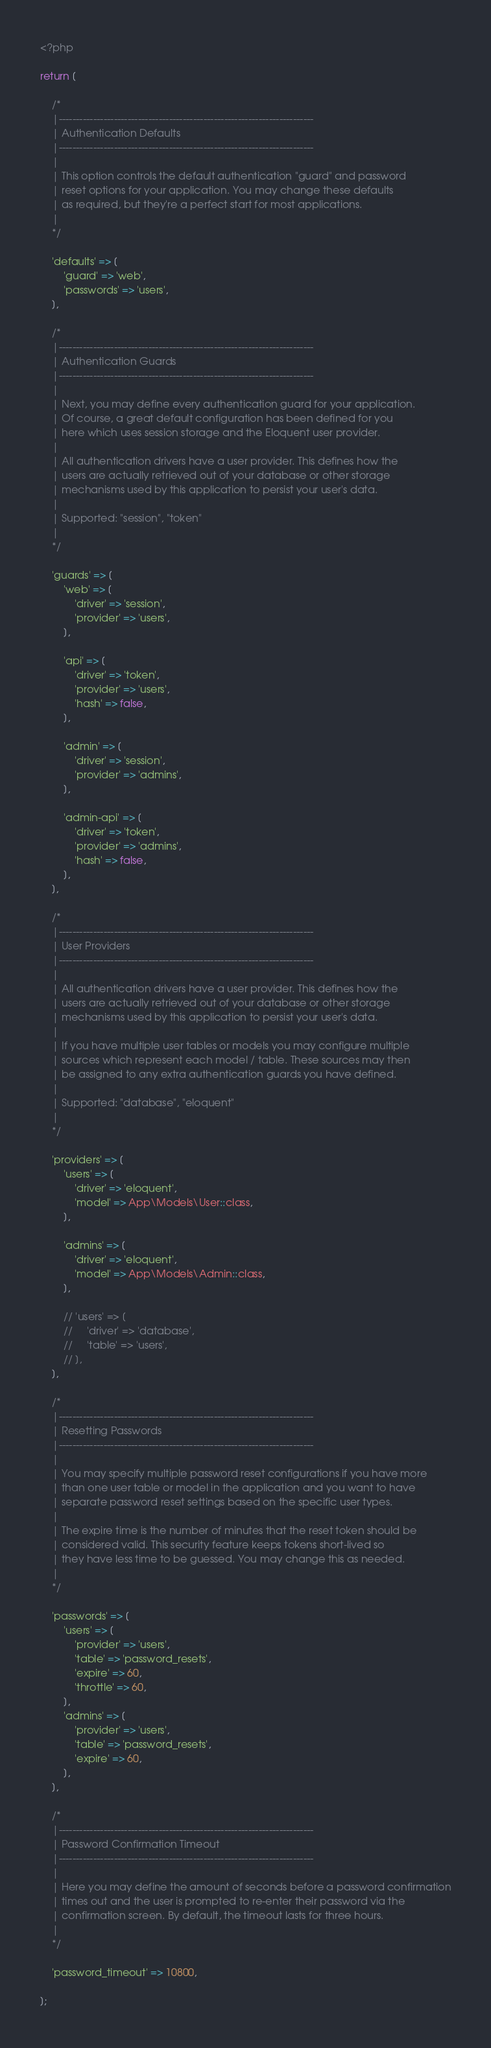<code> <loc_0><loc_0><loc_500><loc_500><_PHP_><?php

return [

    /*
    |--------------------------------------------------------------------------
    | Authentication Defaults
    |--------------------------------------------------------------------------
    |
    | This option controls the default authentication "guard" and password
    | reset options for your application. You may change these defaults
    | as required, but they're a perfect start for most applications.
    |
    */

    'defaults' => [
        'guard' => 'web',
        'passwords' => 'users',
    ],

    /*
    |--------------------------------------------------------------------------
    | Authentication Guards
    |--------------------------------------------------------------------------
    |
    | Next, you may define every authentication guard for your application.
    | Of course, a great default configuration has been defined for you
    | here which uses session storage and the Eloquent user provider.
    |
    | All authentication drivers have a user provider. This defines how the
    | users are actually retrieved out of your database or other storage
    | mechanisms used by this application to persist your user's data.
    |
    | Supported: "session", "token"
    |
    */

    'guards' => [
        'web' => [
            'driver' => 'session',
            'provider' => 'users',
        ],

        'api' => [
            'driver' => 'token',
            'provider' => 'users',
            'hash' => false,
        ],

        'admin' => [
            'driver' => 'session',
            'provider' => 'admins',
        ],
    
        'admin-api' => [
            'driver' => 'token',
            'provider' => 'admins',
            'hash' => false,
        ],
    ],

    /*
    |--------------------------------------------------------------------------
    | User Providers
    |--------------------------------------------------------------------------
    |
    | All authentication drivers have a user provider. This defines how the
    | users are actually retrieved out of your database or other storage
    | mechanisms used by this application to persist your user's data.
    |
    | If you have multiple user tables or models you may configure multiple
    | sources which represent each model / table. These sources may then
    | be assigned to any extra authentication guards you have defined.
    |
    | Supported: "database", "eloquent"
    |
    */

    'providers' => [
        'users' => [
            'driver' => 'eloquent',
            'model' => App\Models\User::class,
        ],

        'admins' => [
            'driver' => 'eloquent',
            'model' => App\Models\Admin::class,
        ],

        // 'users' => [
        //     'driver' => 'database',
        //     'table' => 'users',
        // ],
    ],

    /*
    |--------------------------------------------------------------------------
    | Resetting Passwords
    |--------------------------------------------------------------------------
    |
    | You may specify multiple password reset configurations if you have more
    | than one user table or model in the application and you want to have
    | separate password reset settings based on the specific user types.
    |
    | The expire time is the number of minutes that the reset token should be
    | considered valid. This security feature keeps tokens short-lived so
    | they have less time to be guessed. You may change this as needed.
    |
    */

    'passwords' => [
        'users' => [
            'provider' => 'users',
            'table' => 'password_resets',
            'expire' => 60,
            'throttle' => 60,
        ],
        'admins' => [
            'provider' => 'users',
            'table' => 'password_resets',
            'expire' => 60,
        ],
    ],

    /*
    |--------------------------------------------------------------------------
    | Password Confirmation Timeout
    |--------------------------------------------------------------------------
    |
    | Here you may define the amount of seconds before a password confirmation
    | times out and the user is prompted to re-enter their password via the
    | confirmation screen. By default, the timeout lasts for three hours.
    |
    */

    'password_timeout' => 10800,

];
</code> 